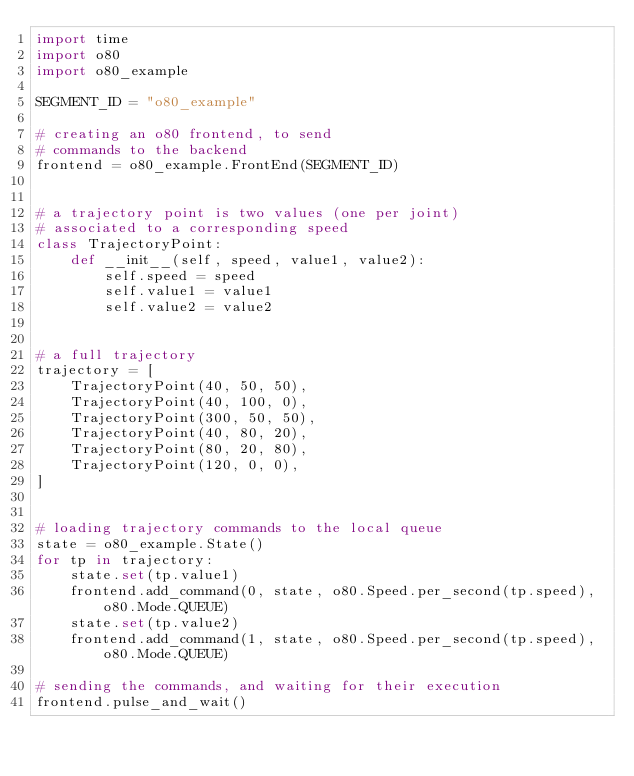<code> <loc_0><loc_0><loc_500><loc_500><_Python_>import time
import o80
import o80_example

SEGMENT_ID = "o80_example"

# creating an o80 frontend, to send
# commands to the backend
frontend = o80_example.FrontEnd(SEGMENT_ID)


# a trajectory point is two values (one per joint)
# associated to a corresponding speed
class TrajectoryPoint:
    def __init__(self, speed, value1, value2):
        self.speed = speed
        self.value1 = value1
        self.value2 = value2


# a full trajectory
trajectory = [
    TrajectoryPoint(40, 50, 50),
    TrajectoryPoint(40, 100, 0),
    TrajectoryPoint(300, 50, 50),
    TrajectoryPoint(40, 80, 20),
    TrajectoryPoint(80, 20, 80),
    TrajectoryPoint(120, 0, 0),
]


# loading trajectory commands to the local queue
state = o80_example.State()
for tp in trajectory:
    state.set(tp.value1)
    frontend.add_command(0, state, o80.Speed.per_second(tp.speed), o80.Mode.QUEUE)
    state.set(tp.value2)
    frontend.add_command(1, state, o80.Speed.per_second(tp.speed), o80.Mode.QUEUE)

# sending the commands, and waiting for their execution
frontend.pulse_and_wait()
</code> 